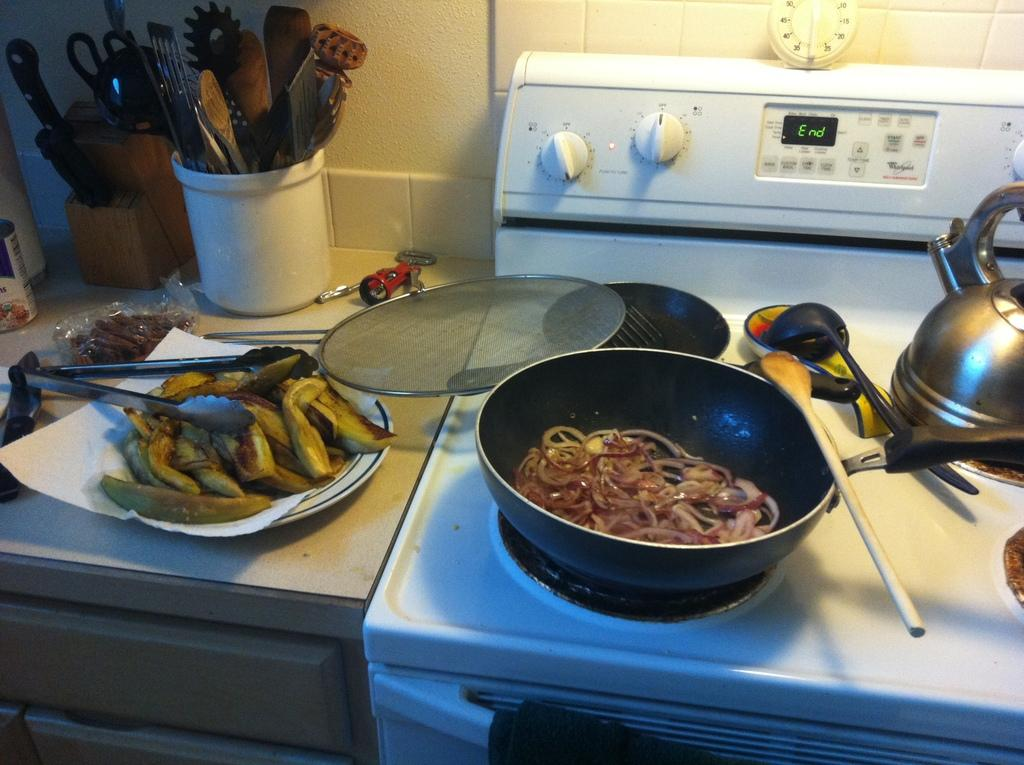<image>
Write a terse but informative summary of the picture. a stove top with the word 'end' on the digital screen 